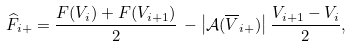Convert formula to latex. <formula><loc_0><loc_0><loc_500><loc_500>\widehat { F } _ { i + } = \frac { F ( V _ { i } ) + F ( V _ { i + 1 } ) } { 2 } \, - \left | \mathcal { A } ( \overline { V } _ { i + } ) \right | \frac { V _ { i + 1 } - V _ { i } } { 2 } ,</formula> 